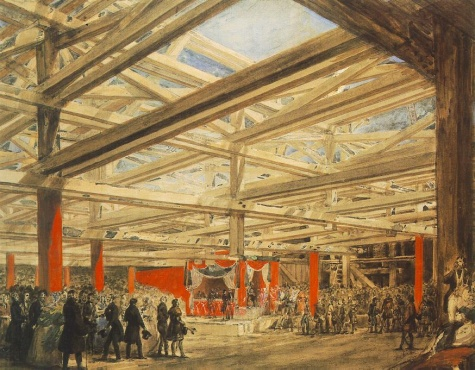What might be the significance of the throne on the stage? The throne on the stage is a strong symbolic element, suggesting an event of political or ceremonial importance. It could be set for a royal address, a court ceremony, or a significant public declaration. The throne's prominence and central placement underscore its importance, marking the event as one reserved for high-ranking individuals or moments of major societal significance, aligning with the grandeur of the setting. 